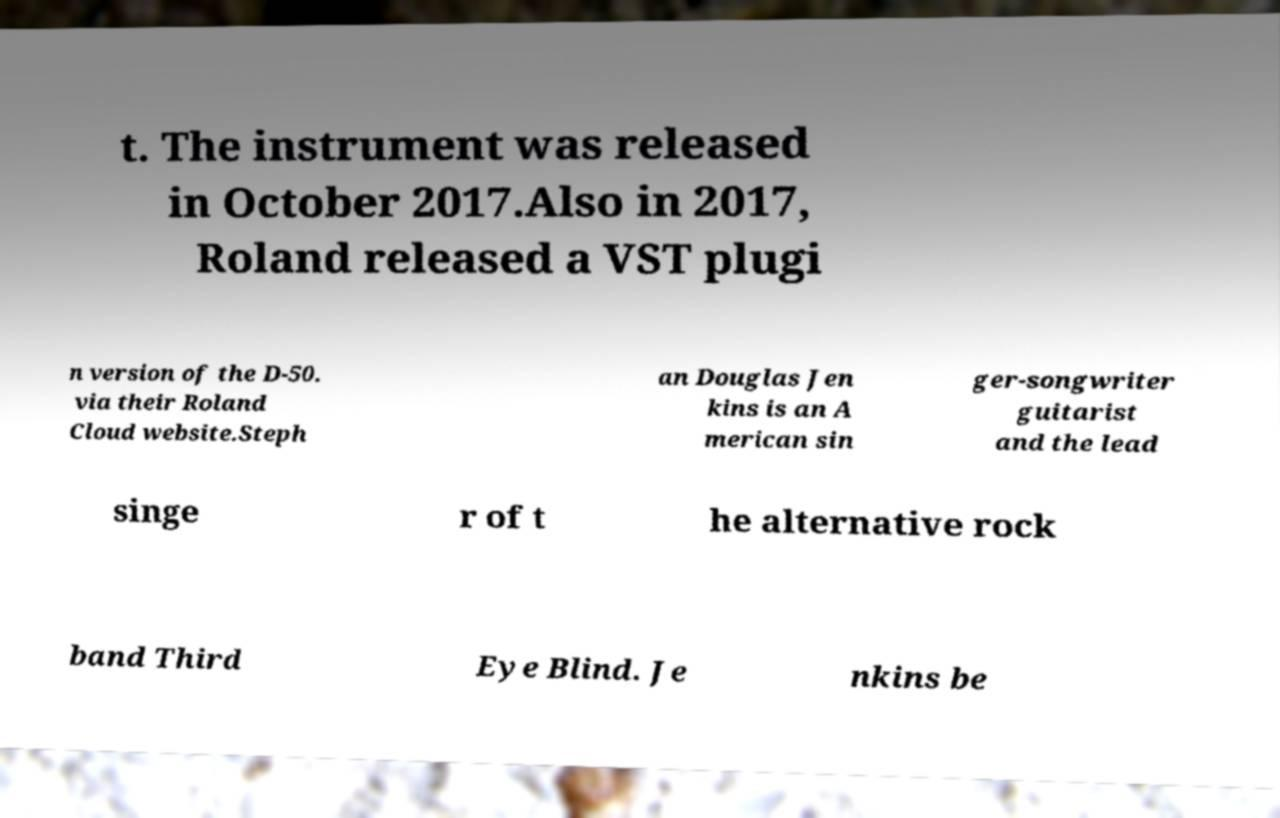I need the written content from this picture converted into text. Can you do that? t. The instrument was released in October 2017.Also in 2017, Roland released a VST plugi n version of the D-50. via their Roland Cloud website.Steph an Douglas Jen kins is an A merican sin ger-songwriter guitarist and the lead singe r of t he alternative rock band Third Eye Blind. Je nkins be 